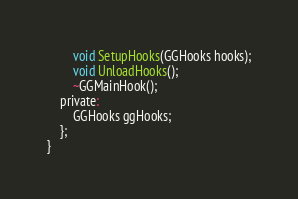Convert code to text. <code><loc_0><loc_0><loc_500><loc_500><_C_>		void SetupHooks(GGHooks hooks);
		void UnloadHooks();
		~GGMainHook();
	private:
		GGHooks ggHooks;
	};
}
</code> 